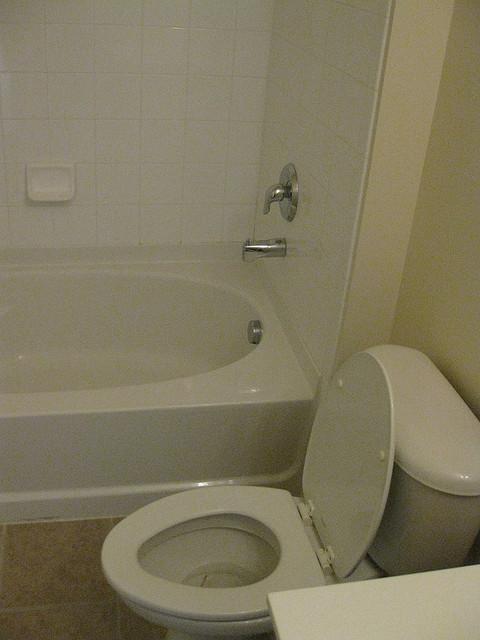What color is the floor?
Write a very short answer. Brown. Is there mold on the tub?
Give a very brief answer. No. What do people do here?
Concise answer only. Pee. Can you see any water in the tub?
Write a very short answer. No. Is there a mirror in the picture?
Quick response, please. No. What color is the seat?
Concise answer only. White. Is the toilet seat up or down?
Give a very brief answer. Down. What color is the water in the toilet?
Quick response, please. Clear. Is the wall decorated with a mosaic?
Write a very short answer. No. What sits on the back of the toilet?
Give a very brief answer. Nothing. What is the purpose of the silver hose in the back?
Concise answer only. Water. IS there a bathtub?
Keep it brief. Yes. Is the tank proportional to the bowl?
Write a very short answer. Yes. Is the bathroom clean?
Give a very brief answer. Yes. Is this bathtub filled with water?
Short answer required. No. Is there soap to be seen anywhere?
Write a very short answer. No. Does this room have sufficient natural light?
Write a very short answer. No. 